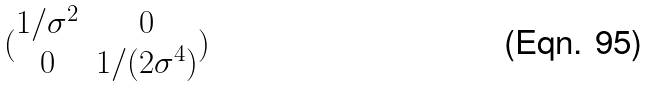<formula> <loc_0><loc_0><loc_500><loc_500>( \begin{matrix} 1 / \sigma ^ { 2 } & 0 \\ 0 & 1 / ( 2 \sigma ^ { 4 } ) \end{matrix} )</formula> 